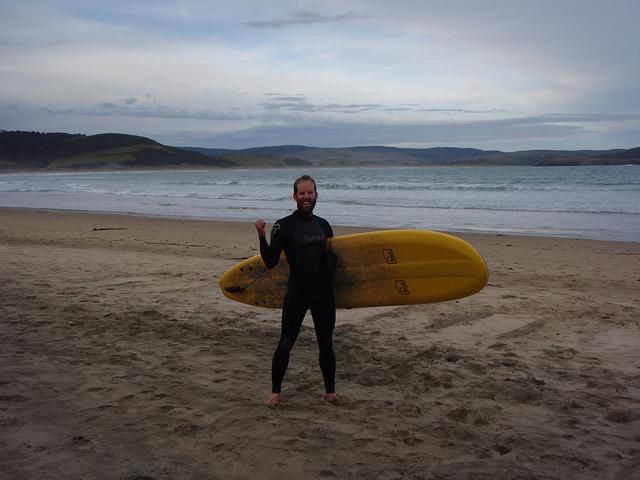What is the man holding?
Answer briefly. Surfboard. Is anyone in the water?
Answer briefly. No. Is he on the beach?
Quick response, please. Yes. What color is the surfboard?
Short answer required. Yellow. What does the hand gesture mean that the guy is making?
Keep it brief. Waving. Is this a mountainous scene?
Be succinct. Yes. Are the men slaves to the surfboards?
Write a very short answer. No. 